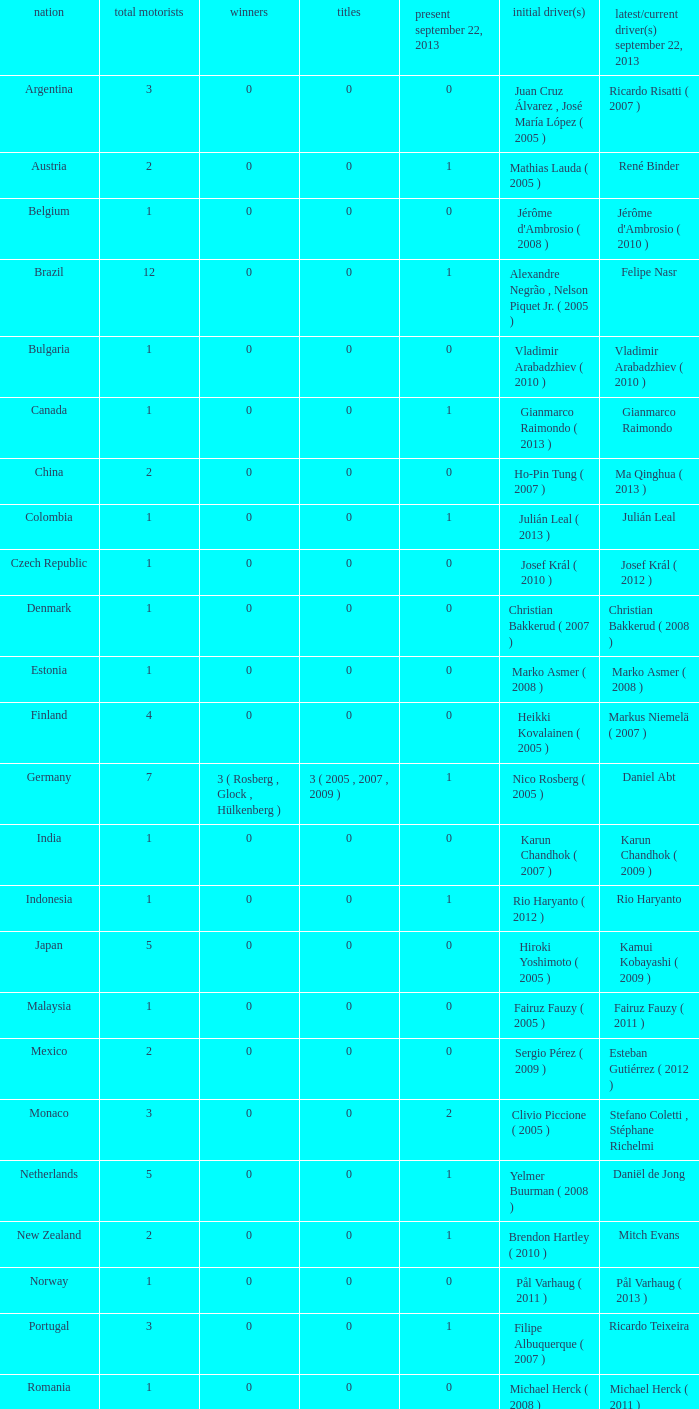How many champions were there when the first driver was hiroki yoshimoto ( 2005 )? 0.0. 